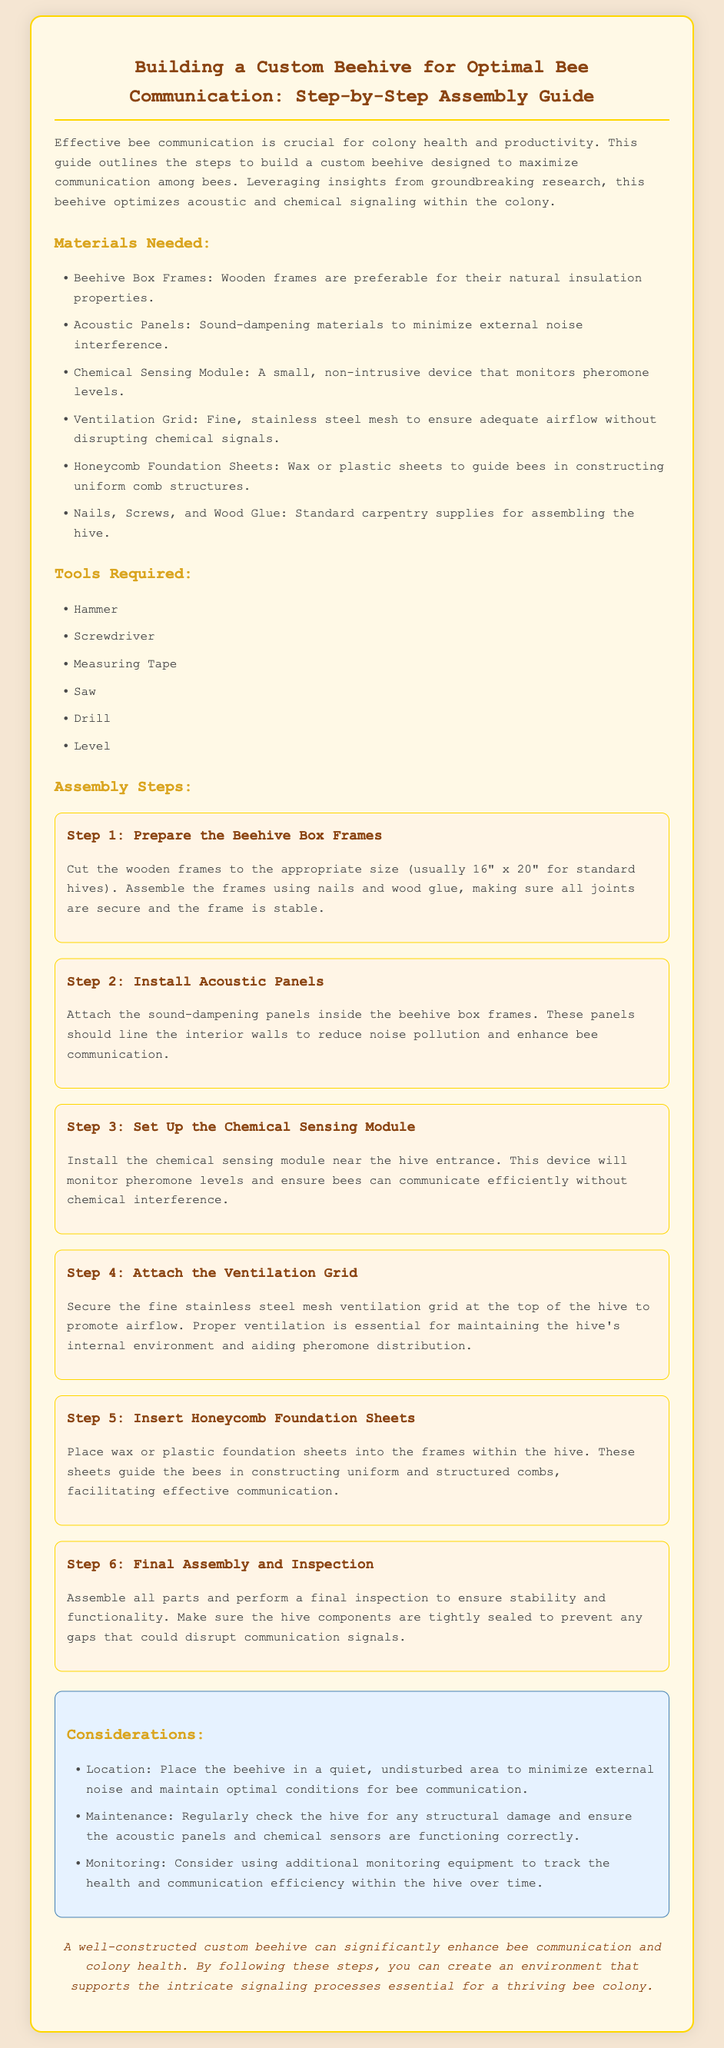What are the dimensions for standard hive frames? The document states that the appropriate size for standard hives is usually 16" x 20".
Answer: 16" x 20" What type of materials are used for the beehive box frames? The instructions mention that wooden frames are preferable due to their natural insulation properties.
Answer: Wooden frames What is the purpose of the acoustic panels? The panels are intended to reduce noise pollution and enhance bee communication inside the hive.
Answer: Reduce noise pollution Where should the chemical sensing module be installed? The document specifies that it should be installed near the hive entrance.
Answer: Near the hive entrance What should you ensure about hive components during final assembly? It's important to ensure that the hive components are tightly sealed to prevent any gaps that could disrupt communication signals.
Answer: Tightly sealed Why is proper ventilation essential in the hive? Proper ventilation is necessary for maintaining the hive's internal environment and aiding pheromone distribution.
Answer: Maintaining internal environment What is recommended for the location of the beehive? The document suggests placing the beehive in a quiet, undisturbed area.
Answer: Quiet, undisturbed area What equipment could be used to track hive health over time? The document mentions considering additional monitoring equipment for tracking health and communication efficiency.
Answer: Monitoring equipment What is one consideration for maintaining the hive? Regular checks for structural damage is mentioned in the considerations section of the document.
Answer: Structural damage checks 